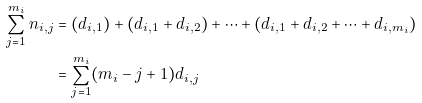<formula> <loc_0><loc_0><loc_500><loc_500>\sum _ { j = 1 } ^ { m _ { i } } n _ { i , j } & = ( d _ { i , 1 } ) + ( d _ { i , 1 } + d _ { i , 2 } ) + \cdots + ( d _ { i , 1 } + d _ { i , 2 } + \cdots + d _ { i , m _ { i } } ) \\ & = \sum _ { j = 1 } ^ { m _ { i } } ( m _ { i } - j + 1 ) d _ { i , j }</formula> 